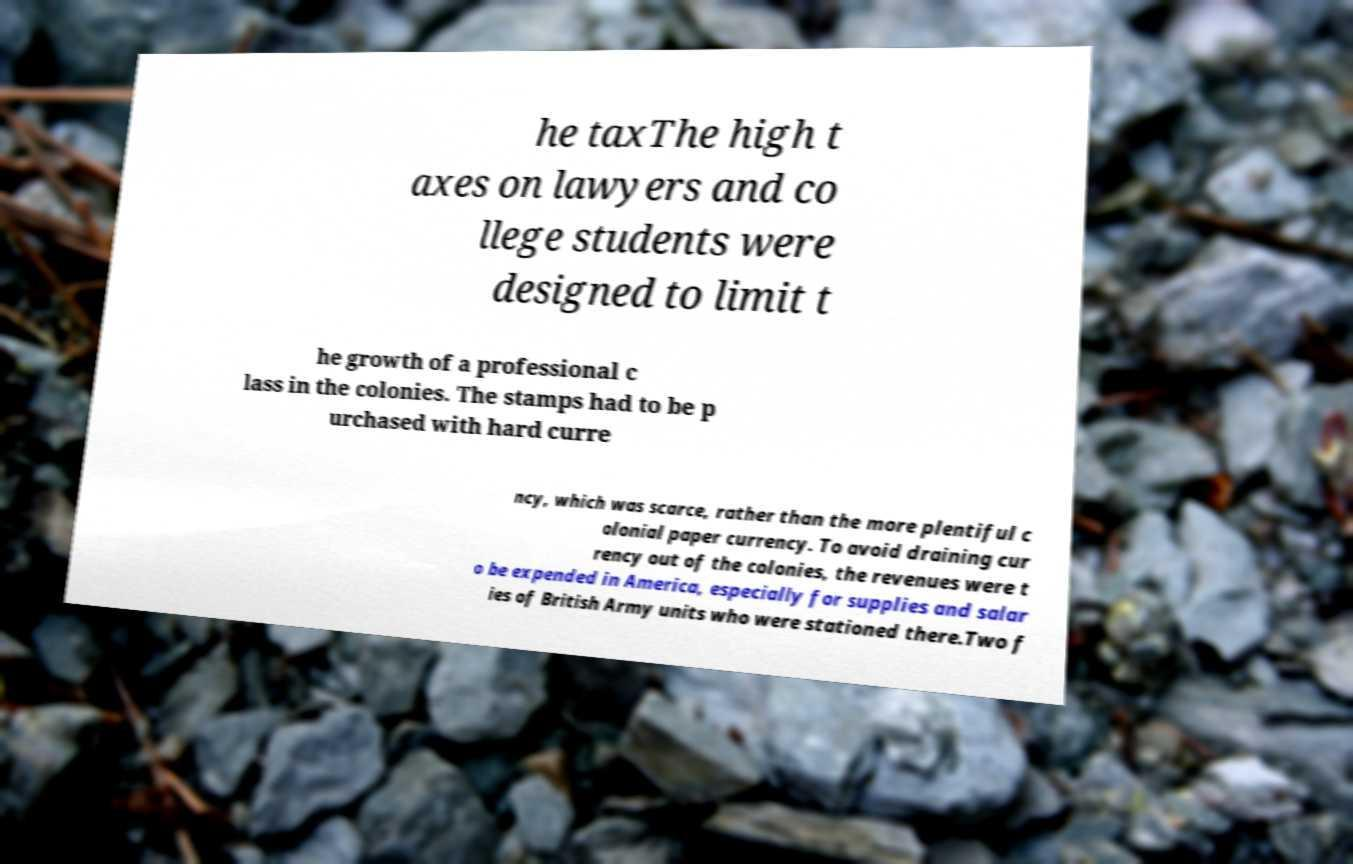Could you extract and type out the text from this image? he taxThe high t axes on lawyers and co llege students were designed to limit t he growth of a professional c lass in the colonies. The stamps had to be p urchased with hard curre ncy, which was scarce, rather than the more plentiful c olonial paper currency. To avoid draining cur rency out of the colonies, the revenues were t o be expended in America, especially for supplies and salar ies of British Army units who were stationed there.Two f 